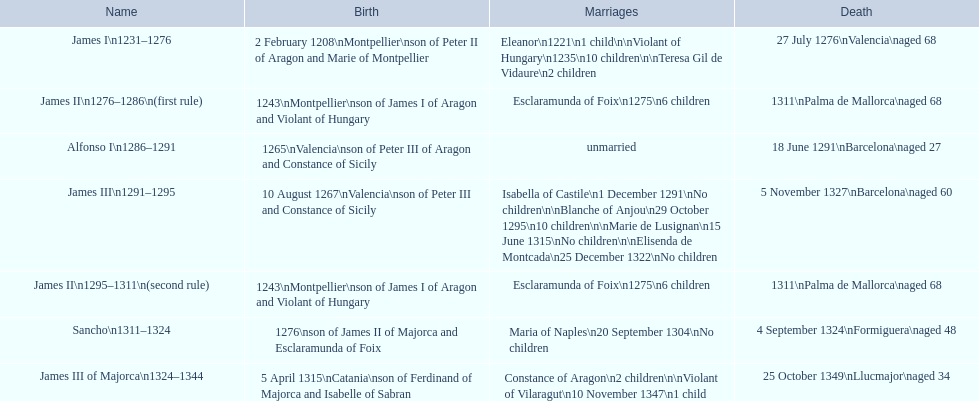Was the birth year of james iii or sancho 1276? Sancho. 